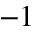<formula> <loc_0><loc_0><loc_500><loc_500>^ { - 1 }</formula> 